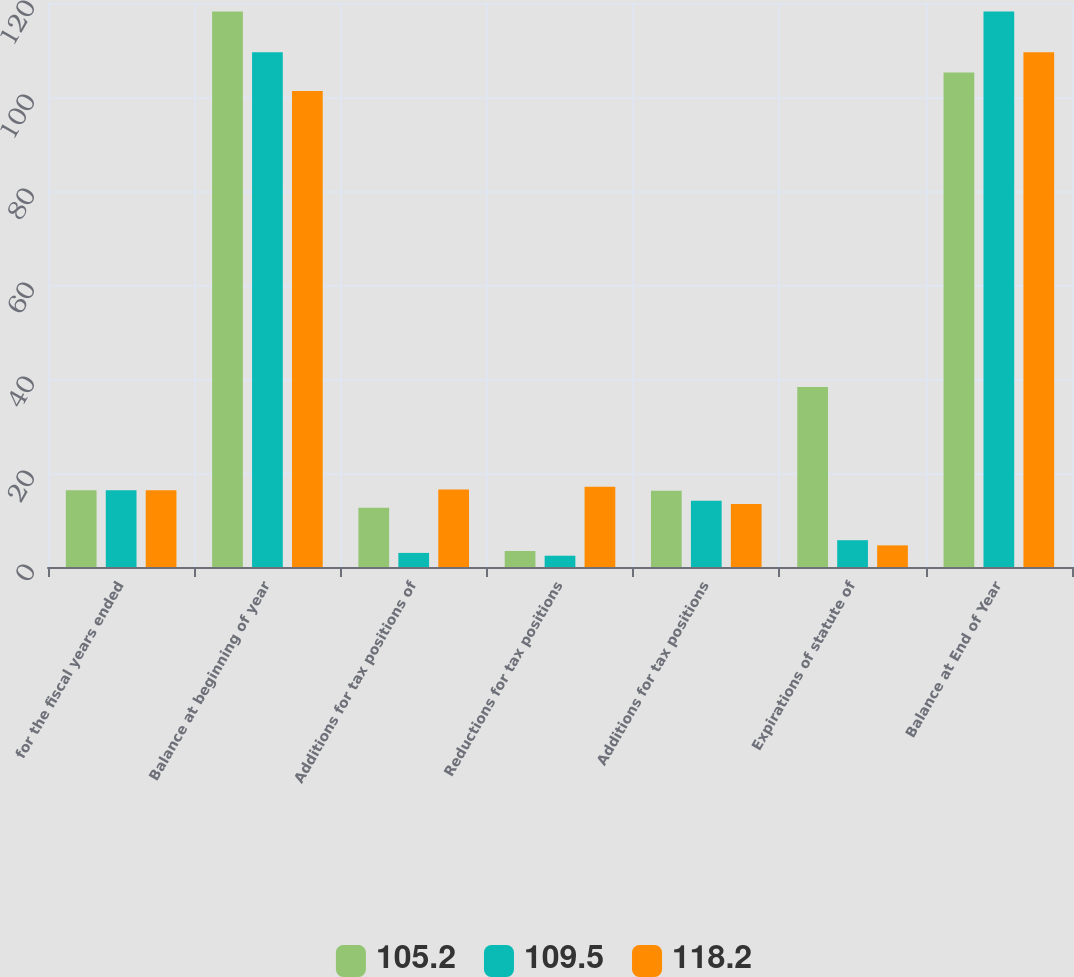Convert chart. <chart><loc_0><loc_0><loc_500><loc_500><stacked_bar_chart><ecel><fcel>for the fiscal years ended<fcel>Balance at beginning of year<fcel>Additions for tax positions of<fcel>Reductions for tax positions<fcel>Additions for tax positions<fcel>Expirations of statute of<fcel>Balance at End of Year<nl><fcel>105.2<fcel>16.35<fcel>118.2<fcel>12.6<fcel>3.4<fcel>16.2<fcel>38.3<fcel>105.2<nl><fcel>109.5<fcel>16.35<fcel>109.5<fcel>3<fcel>2.4<fcel>14.1<fcel>5.7<fcel>118.2<nl><fcel>118.2<fcel>16.35<fcel>101.3<fcel>16.5<fcel>17.1<fcel>13.4<fcel>4.6<fcel>109.5<nl></chart> 